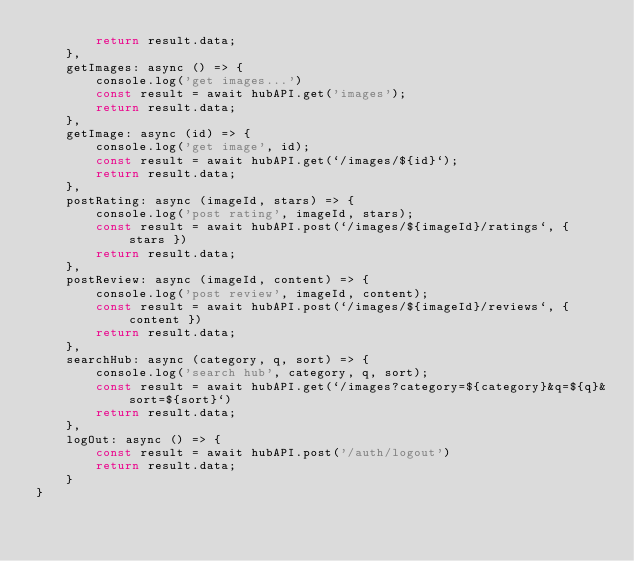Convert code to text. <code><loc_0><loc_0><loc_500><loc_500><_JavaScript_>		return result.data;
	},
	getImages: async () => {
		console.log('get images...')
		const result = await hubAPI.get('images');
		return result.data;
	},
	getImage: async (id) => {
		console.log('get image', id);
		const result = await hubAPI.get(`/images/${id}`);
		return result.data;
	},
	postRating: async (imageId, stars) => {
		console.log('post rating', imageId, stars);
		const result = await hubAPI.post(`/images/${imageId}/ratings`, { stars })
		return result.data;
	},
	postReview: async (imageId, content) => {
		console.log('post review', imageId, content);
		const result = await hubAPI.post(`/images/${imageId}/reviews`, { content })
		return result.data;
	},
	searchHub: async (category, q, sort) => {
		console.log('search hub', category, q, sort);
		const result = await hubAPI.get(`/images?category=${category}&q=${q}&sort=${sort}`)
		return result.data;
	},
	logOut: async () => {
		const result = await hubAPI.post('/auth/logout')
		return result.data;
	}
}</code> 